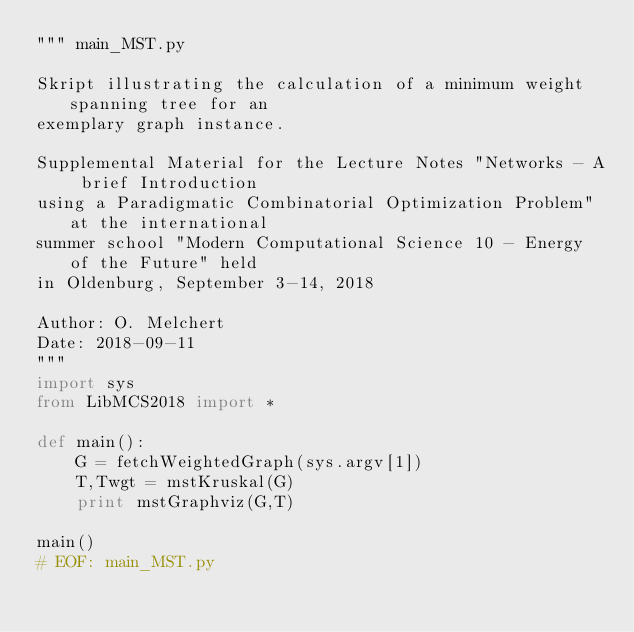Convert code to text. <code><loc_0><loc_0><loc_500><loc_500><_Python_>""" main_MST.py

Skript illustrating the calculation of a minimum weight spanning tree for an
exemplary graph instance.

Supplemental Material for the Lecture Notes "Networks - A brief Introduction
using a Paradigmatic Combinatorial Optimization Problem" at the international
summer school "Modern Computational Science 10 - Energy of the Future" held
in Oldenburg, September 3-14, 2018

Author: O. Melchert
Date: 2018-09-11
"""
import sys
from LibMCS2018 import *

def main():
    G = fetchWeightedGraph(sys.argv[1])
    T,Twgt = mstKruskal(G)
    print mstGraphviz(G,T)

main()
# EOF: main_MST.py
</code> 